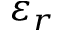Convert formula to latex. <formula><loc_0><loc_0><loc_500><loc_500>\varepsilon _ { r }</formula> 